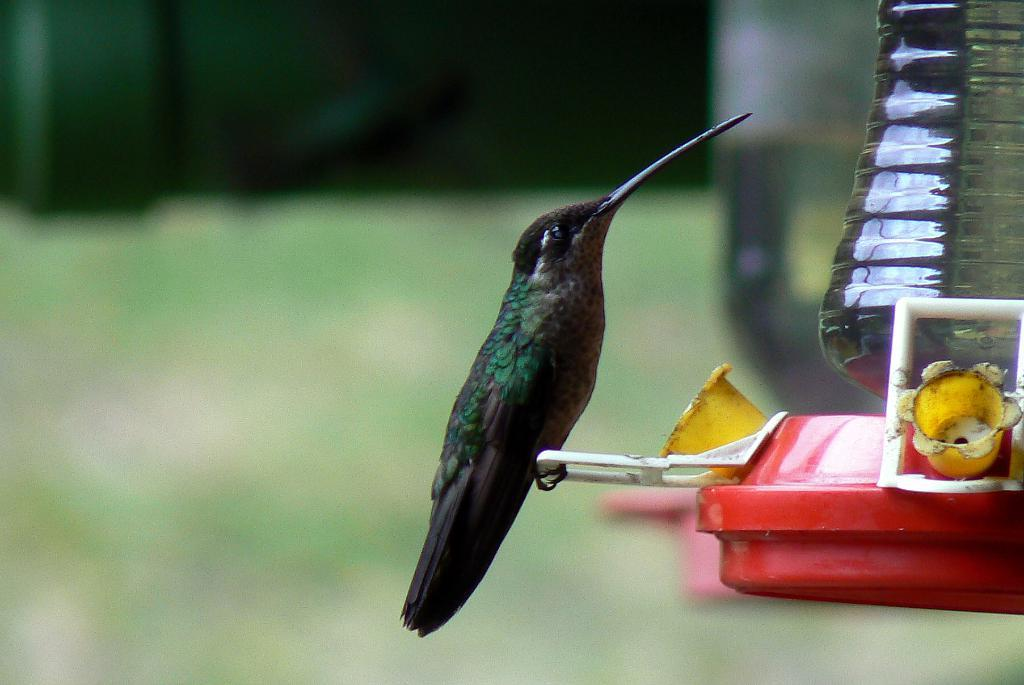What type of animal is in the image? There is a bird in the image. What is the bird standing on? The bird is standing on a handle. What material is visible in the image? There is glass visible in the image. What color is the object in the image? There is a red object in the image. What can be seen in the background of the image? There are trees and grass in the background of the image. How many eyes does the wheel have in the image? There is no wheel present in the image, so it is not possible to determine how many eyes it might have. 